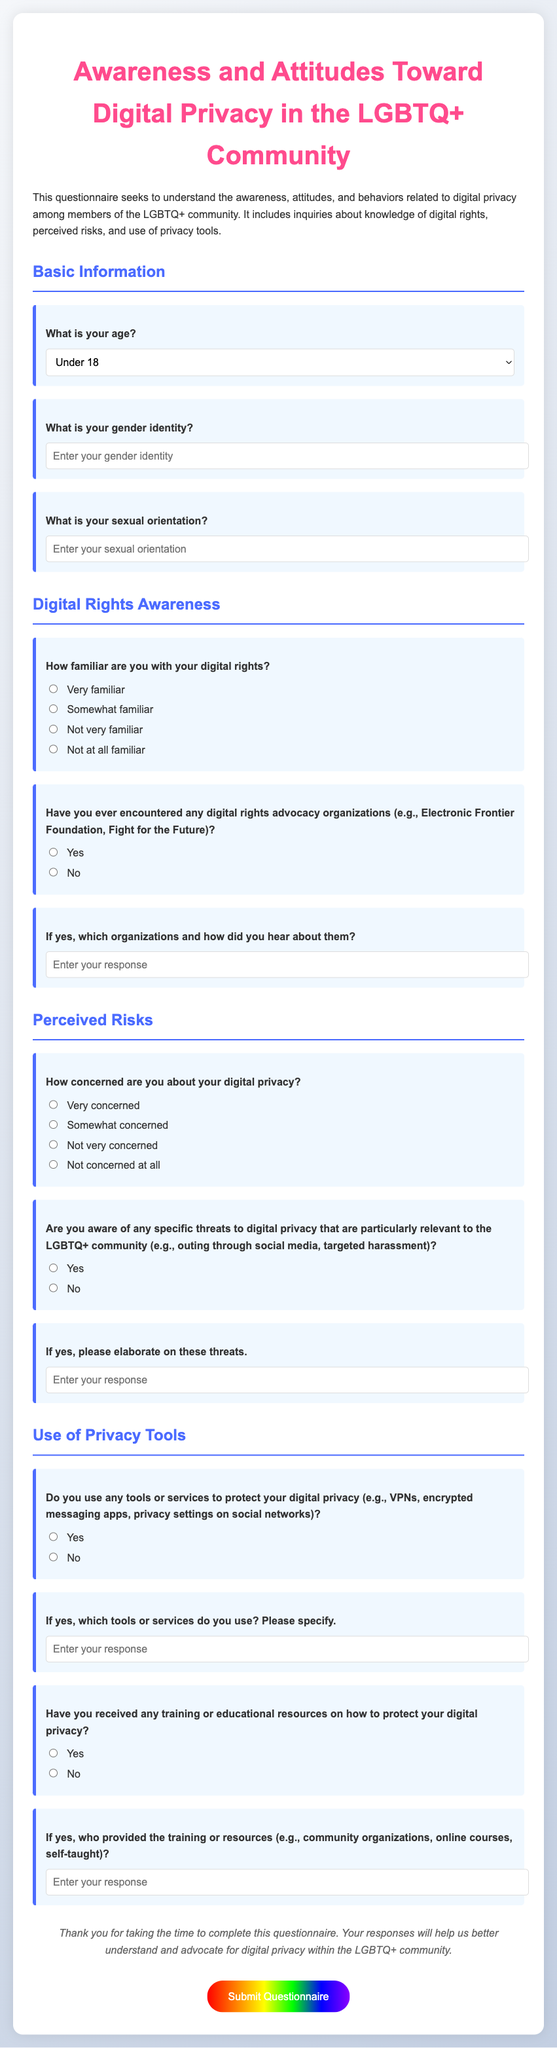What is the title of the questionnaire? The title is provided at the beginning of the document, indicating the focus of the questionnaire.
Answer: Awareness and Attitudes Toward Digital Privacy in the LGBTQ+ Community What section comes after Basic Information? The document is organized into sections, and the next section is mentioned after Basic Information.
Answer: Digital Rights Awareness How many options are there for the question about age? The number of options is indicated in the age selection dropdown within the Basic Information section.
Answer: 7 Which organization is mentioned as an example for digital rights advocacy? This specific organization is used as an example in the questionnaire regarding digital rights advocacy.
Answer: Electronic Frontier Foundation What is the color of the button to submit the questionnaire? The color of the button is described in the styling section of the document.
Answer: White How does the document describe the visual theme of the background? The visual theme is indicated through a gradient in the styling of the document.
Answer: Linear gradient What question follows "Are you aware of any specific threats to digital privacy that are particularly relevant to the LGBTQ+ community"? This question is structured as a follow-up to gauge deeper understanding and perceptions of threats mentioned previously.
Answer: If yes, please elaborate on these threats 